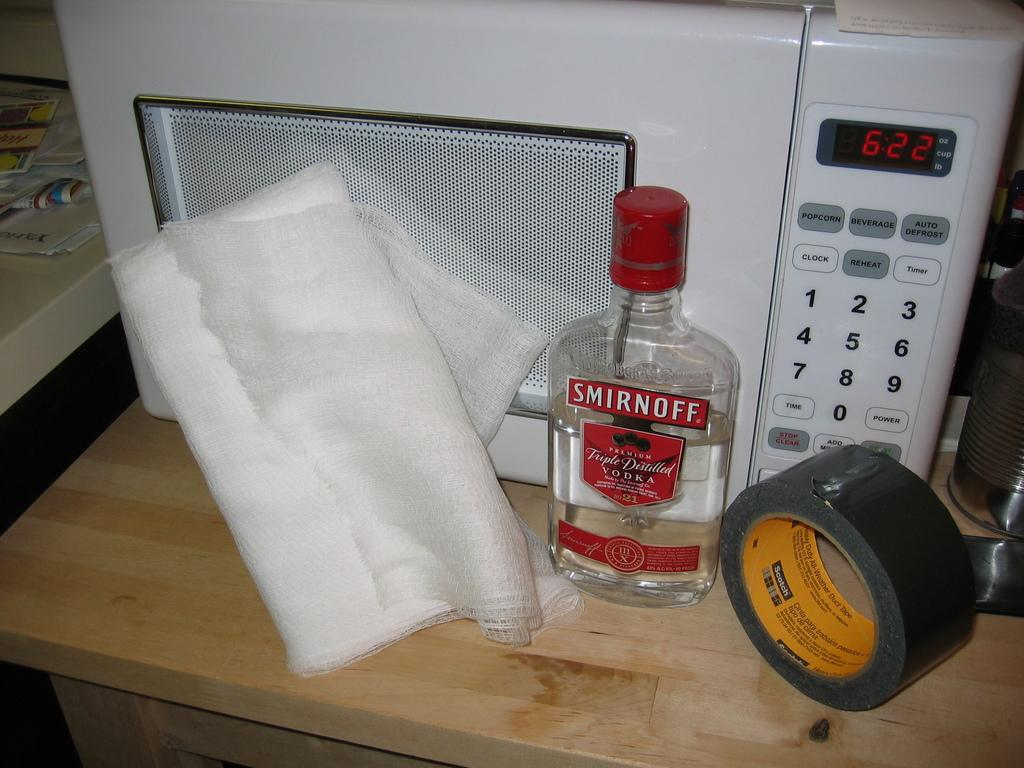What device is present in the image that can be used to measure time? There is a timer in the image. What type of container is visible in the image? There is a bottle in the image. What type of material is present in the image that is commonly used in first aid or personal hygiene? There is cotton in the image. What type of adhesive material is present in the image? There is tape in the image. Where are all these objects located in the image? All these objects are at the right side bottom of the image. What type of crack can be seen in the image? There is no crack present in the image. What type of bait is used to attract fish in the image? There is no bait present in the image. 